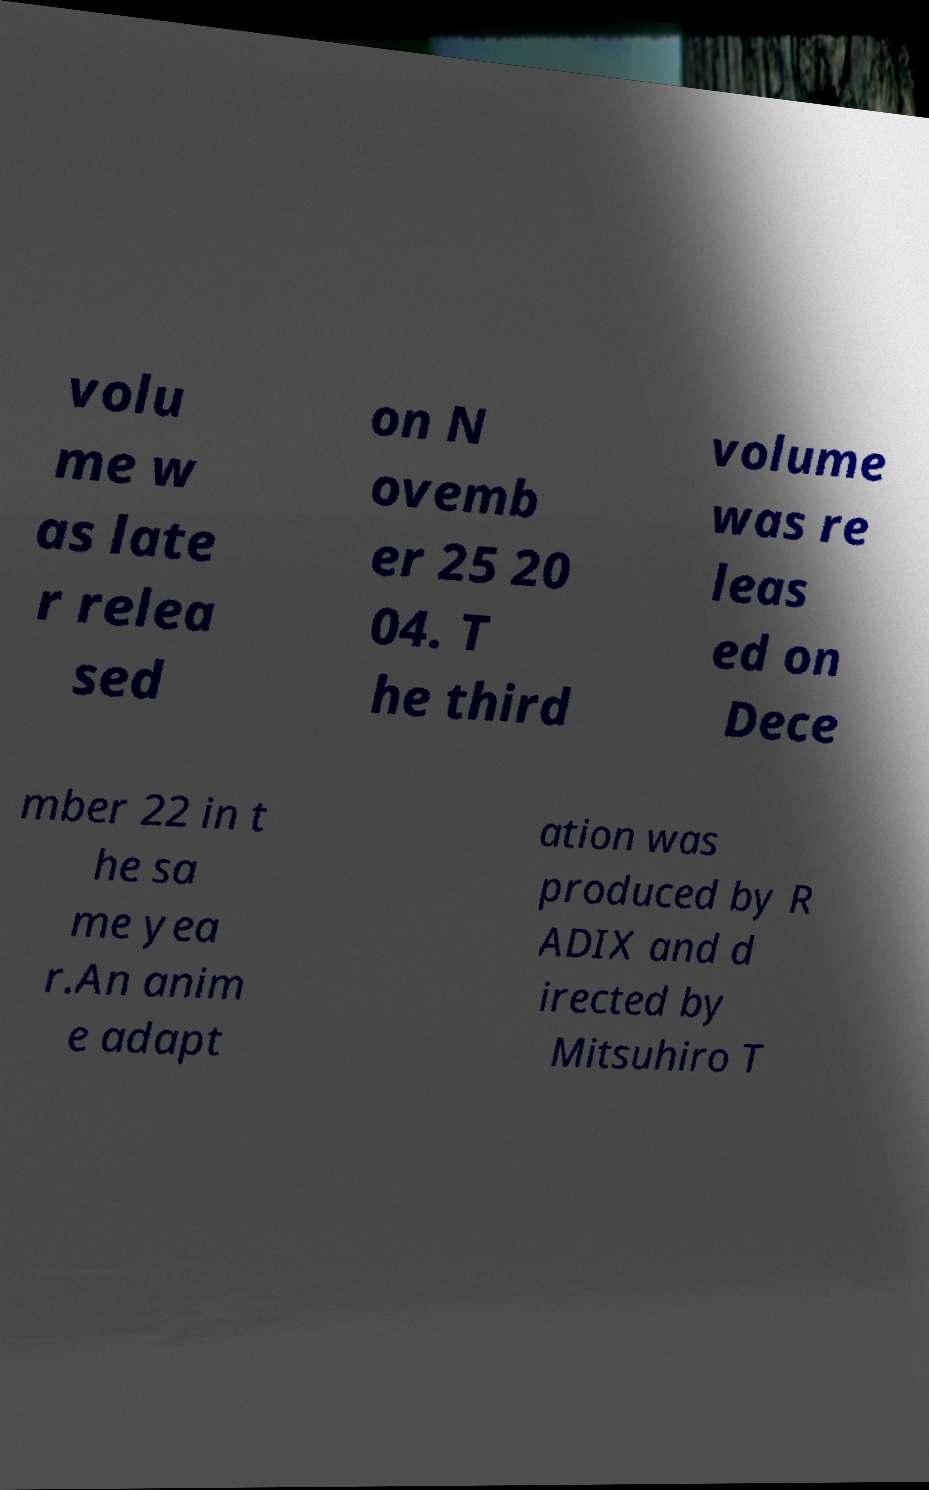Please identify and transcribe the text found in this image. volu me w as late r relea sed on N ovemb er 25 20 04. T he third volume was re leas ed on Dece mber 22 in t he sa me yea r.An anim e adapt ation was produced by R ADIX and d irected by Mitsuhiro T 